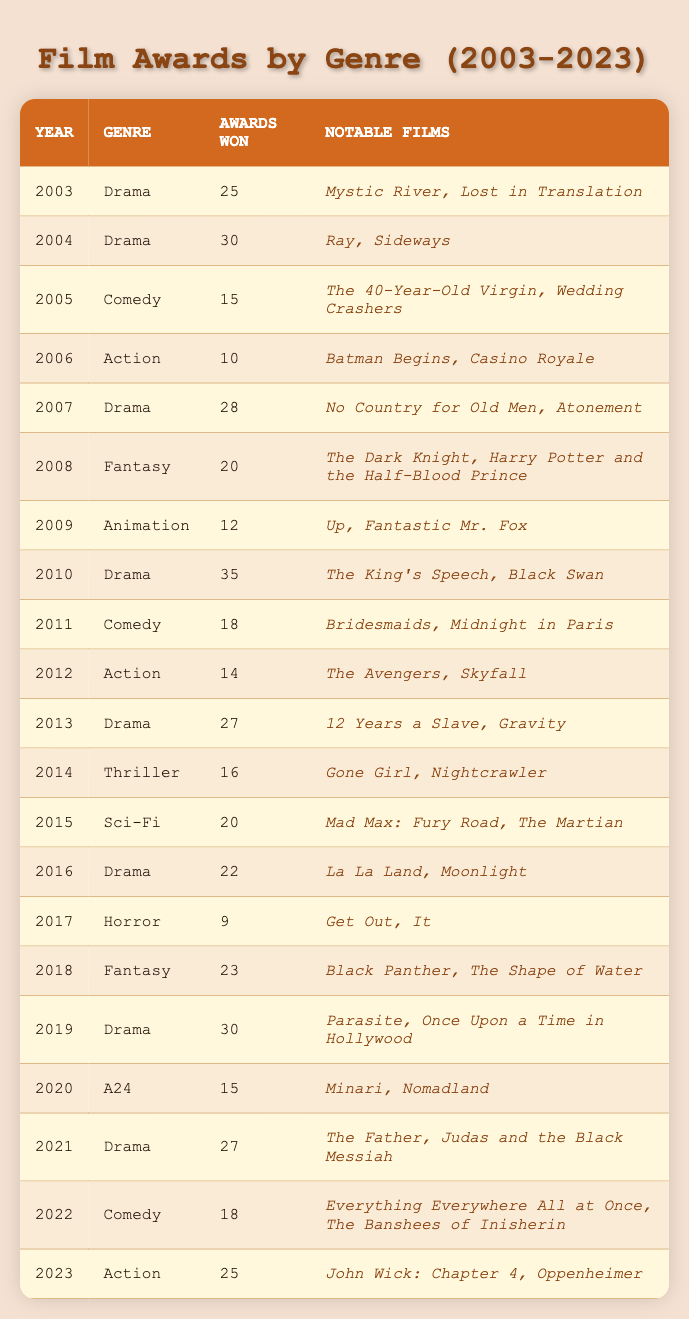What genre won the most awards in 2010? In 2010, the genre listed is Drama, and it won 35 awards, which is higher than any other genre in that year.
Answer: Drama Which genre had the least awards in 2017? In 2017, the only genre listed is Horror, which won 9 awards, making it the genre with the least awards that year.
Answer: Horror What is the total number of awards won by Drama from 2003 to 2023? The total awards for Drama over the years can be summed as follows: 25 (2003) + 30 (2004) + 28 (2007) + 35 (2010) + 27 (2013) + 30 (2019) + 27 (2021) =  27 x 3 = 196
Answer: 196 Did the Thriller genre win more than 20 awards in any year? The Thriller genre was only listed in 2014, winning 16 awards, which is less than 20.
Answer: No Which notable films contributed to the Action genre's success in 2023? The notable films under the Action genre for the year 2023 are John Wick: Chapter 4 and Oppenheimer, which are the specific titles listed alongside the awards won.
Answer: John Wick: Chapter 4 and Oppenheimer What is the average number of awards won by Comedy films from 2005, 2011, and 2022? The awards won by Comedy are 15 (2005) + 18 (2011) + 18 (2022) = 51. Dividing this sum by 3 (the number of years) gives an average of 51/3 = 17.
Answer: 17 How many genres won more than 20 awards in 2018? In 2018, the only genre listed is Fantasy, which won 23 awards, exceeding 20 awards. Thus, one genre won more than 20 awards that year.
Answer: 1 Was the fantasy genre represented in multiple years and what awards did it win? The Fantasy genre appears in 2008 (20 awards) and 2018 (23 awards), indicating its representation in two separate years.
Answer: Yes, 20 awards in 2008 and 23 in 2018 Which year saw the highest number of awards for the Animation genre? The Animation genre is recorded only in 2009 with 12 awards. Since it only appears once, that must be the year it achieved its highest awards.
Answer: 2009 